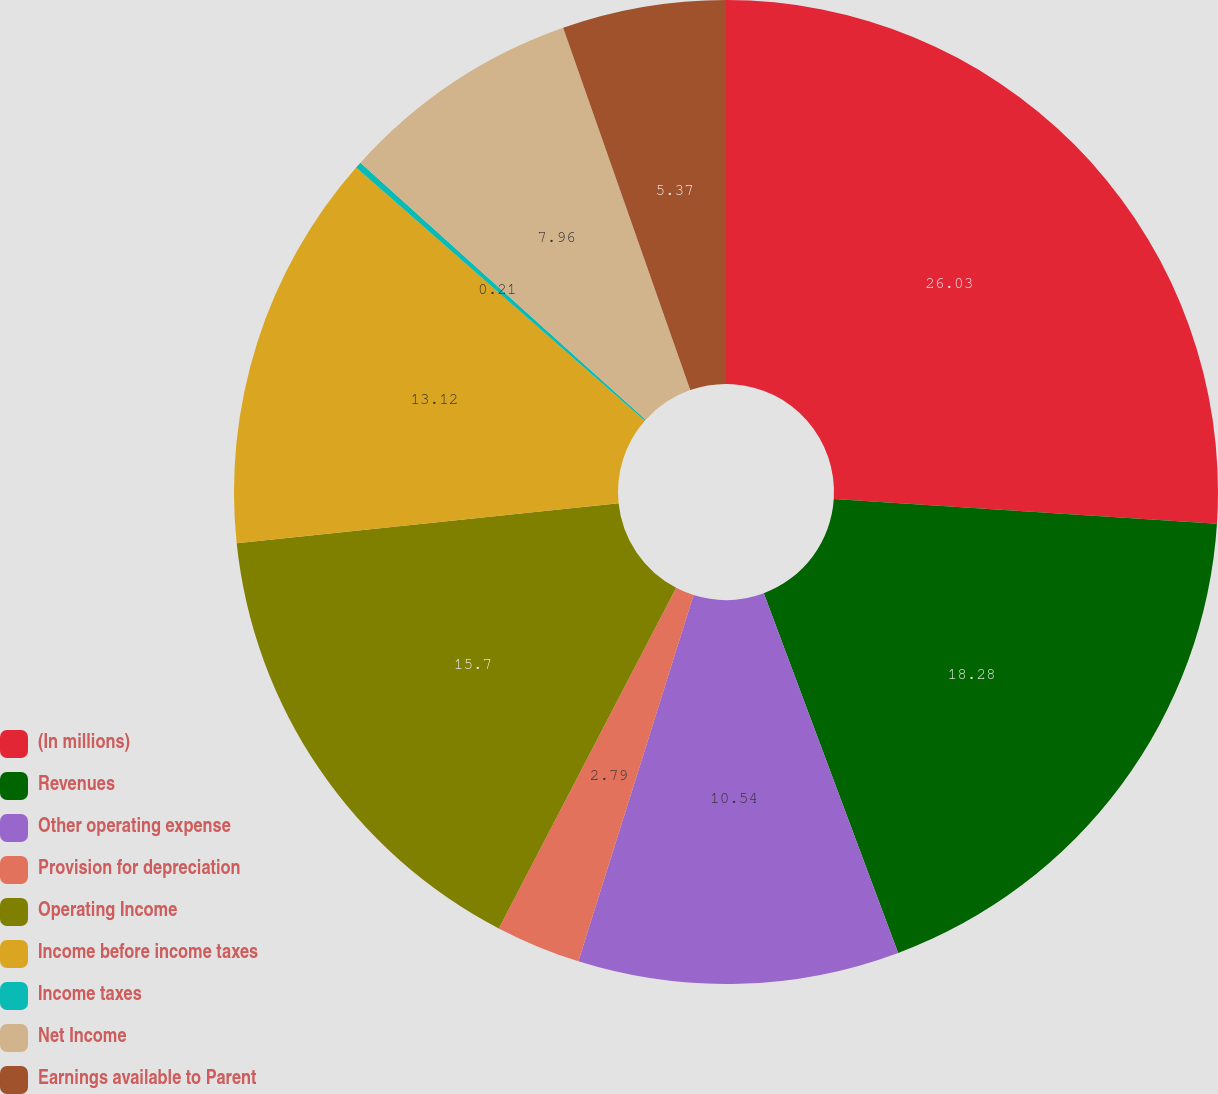Convert chart to OTSL. <chart><loc_0><loc_0><loc_500><loc_500><pie_chart><fcel>(In millions)<fcel>Revenues<fcel>Other operating expense<fcel>Provision for depreciation<fcel>Operating Income<fcel>Income before income taxes<fcel>Income taxes<fcel>Net Income<fcel>Earnings available to Parent<nl><fcel>26.03%<fcel>18.28%<fcel>10.54%<fcel>2.79%<fcel>15.7%<fcel>13.12%<fcel>0.21%<fcel>7.96%<fcel>5.37%<nl></chart> 